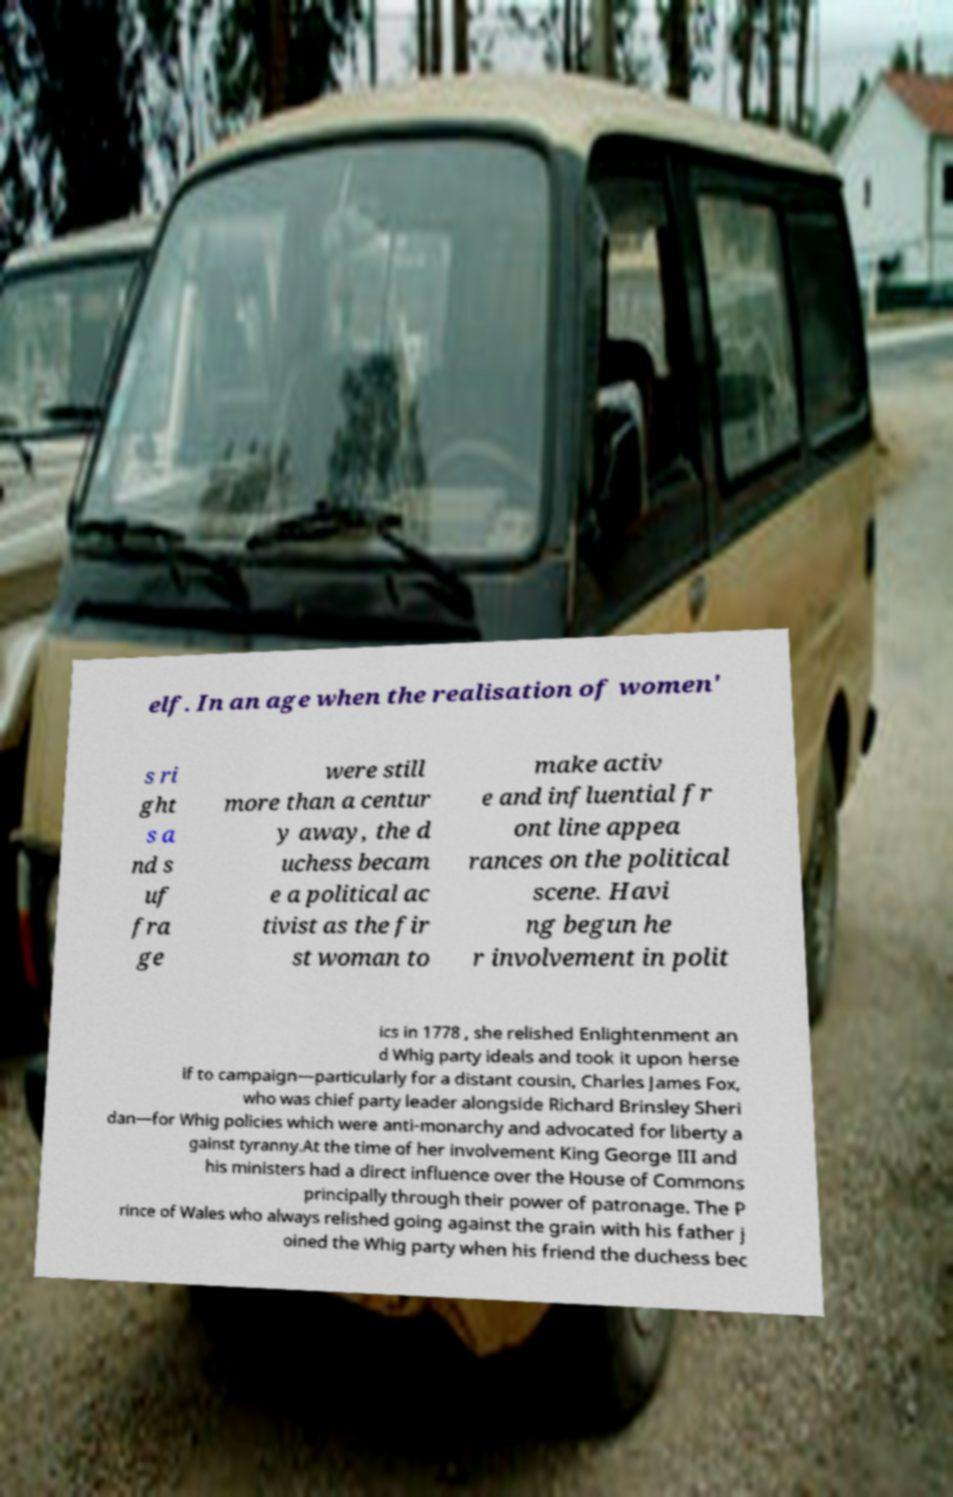Could you assist in decoding the text presented in this image and type it out clearly? elf. In an age when the realisation of women' s ri ght s a nd s uf fra ge were still more than a centur y away, the d uchess becam e a political ac tivist as the fir st woman to make activ e and influential fr ont line appea rances on the political scene. Havi ng begun he r involvement in polit ics in 1778 , she relished Enlightenment an d Whig party ideals and took it upon herse lf to campaign—particularly for a distant cousin, Charles James Fox, who was chief party leader alongside Richard Brinsley Sheri dan—for Whig policies which were anti-monarchy and advocated for liberty a gainst tyranny.At the time of her involvement King George III and his ministers had a direct influence over the House of Commons principally through their power of patronage. The P rince of Wales who always relished going against the grain with his father j oined the Whig party when his friend the duchess bec 